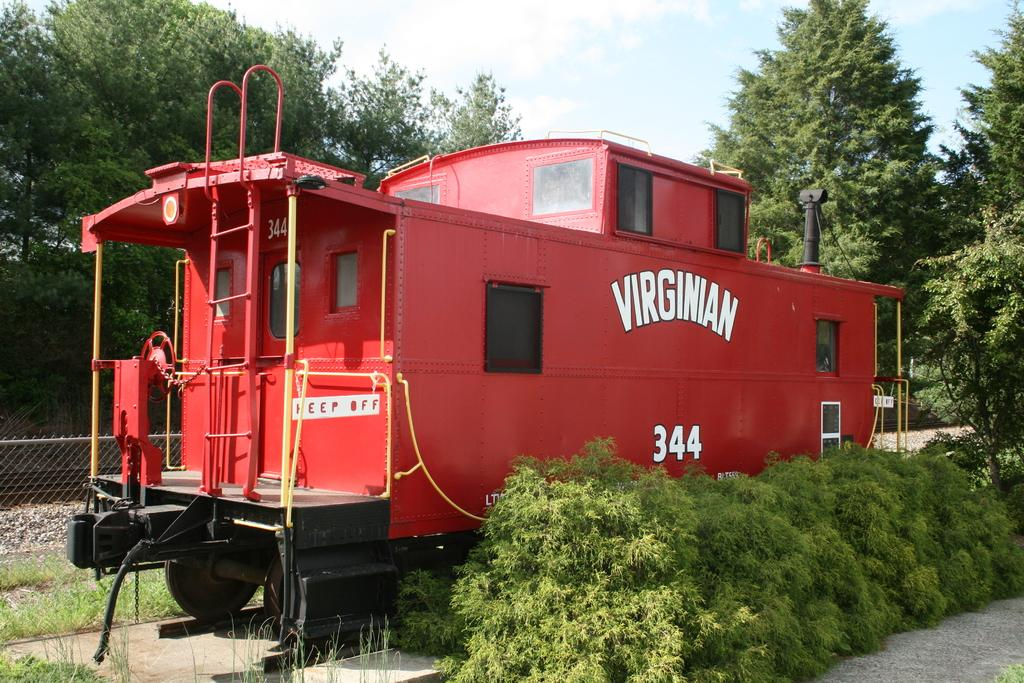What type of vehicle is in the image? There is a red vehicle in the image. What can be seen in the background of the image? Trees are visible in the image. What is the color of the trees? The trees are green. What is visible above the trees in the image? The sky is visible in the image. What colors are present in the sky? The sky is blue and white. What type of meat is being delivered in the red vehicle in the image? There is no indication of meat or a delivery in the image; it only shows a red vehicle and trees in the background. 